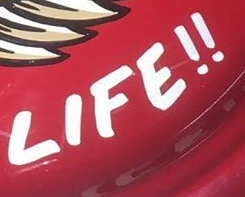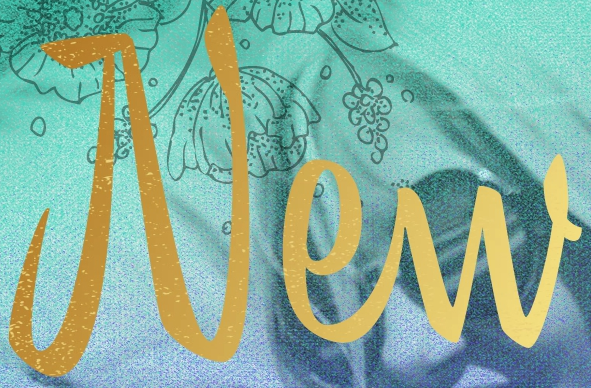Read the text from these images in sequence, separated by a semicolon. LIFE!!; New 